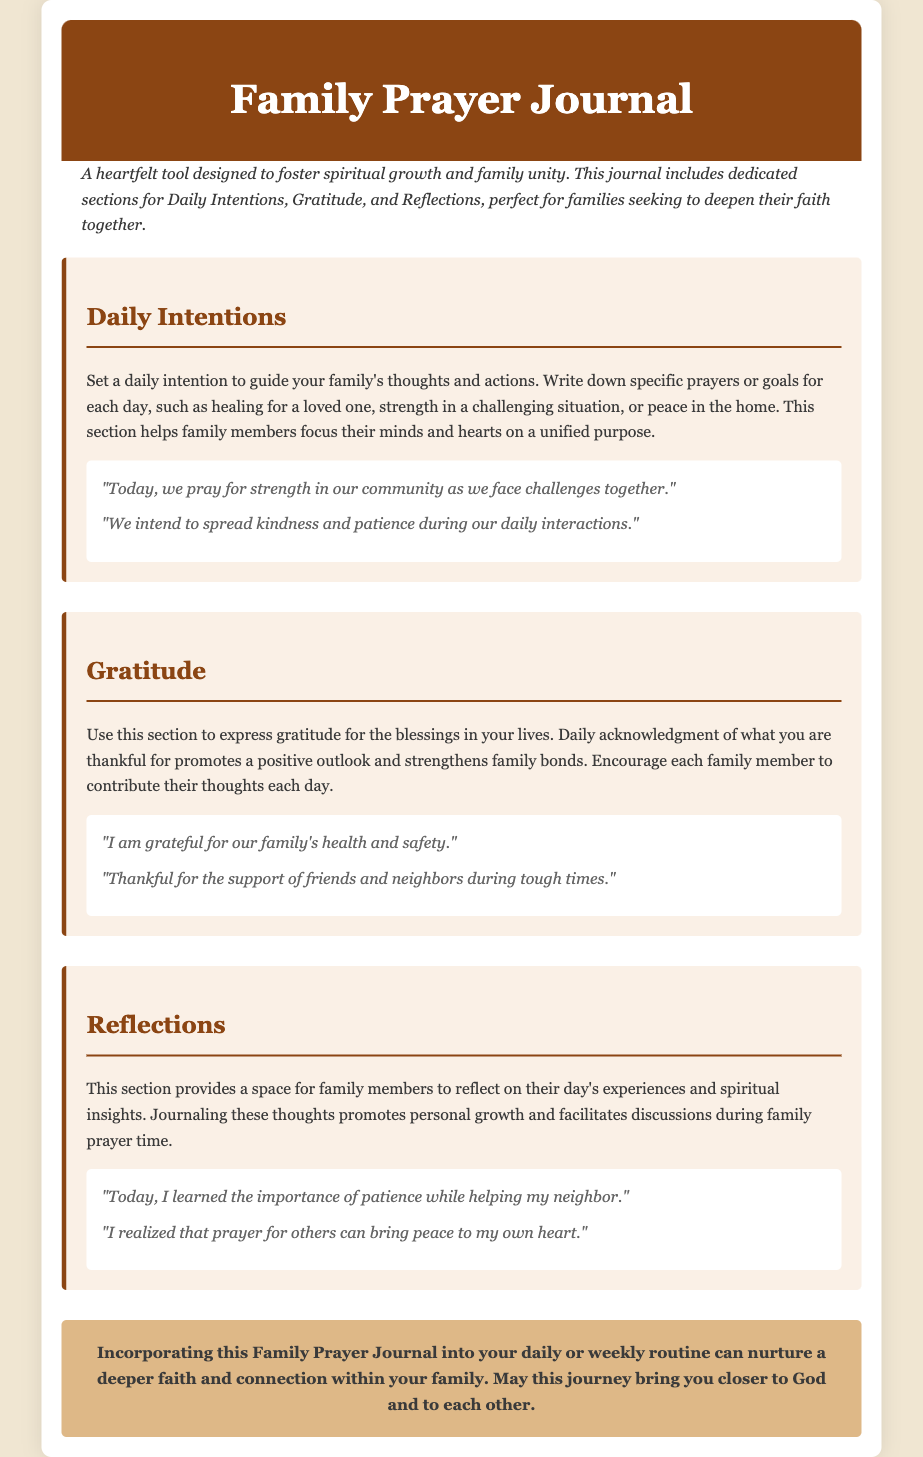What is the title of the document? The title is specified in the HTML document under the <title> tag, which is "Family Prayer Journal Catalog."
Answer: Family Prayer Journal Catalog What are the main sections included in the journal? The main sections are mentioned in the body of the HTML document, specifically as the key areas for writing, which are "Daily Intentions," "Gratitude," and "Reflections."
Answer: Daily Intentions, Gratitude, Reflections What color is the background of the page? The background color of the page is defined in the CSS section of the document, which is #f0e6d2.
Answer: #f0e6d2 How many example entries are provided under the Gratitude section? The specific number of example entries in the Gratitude section can be counted from the content provided, which shows two example entries.
Answer: 2 What is the main purpose of the Family Prayer Journal? The purpose is summarized in the description section of the document, stating that it is a "heartfelt tool designed to foster spiritual growth and family unity."
Answer: Foster spiritual growth and family unity What color is used for the section titles? The color of the section titles is mentioned in the CSS, specifically defined as #8b4513.
Answer: #8b4513 What is one of the intentions mentioned as an example? An example of an intention can be found in the example entries of the Daily Intentions section, specifically the statement about praying for community strength.
Answer: "Today, we pray for strength in our community as we face challenges together." What type of content can family members write in the Reflections section? The Reflections section is described as a space for family members to journal their thoughts, focusing on their day’s experiences and spiritual insights.
Answer: Thoughts on daily experiences and spiritual insights 